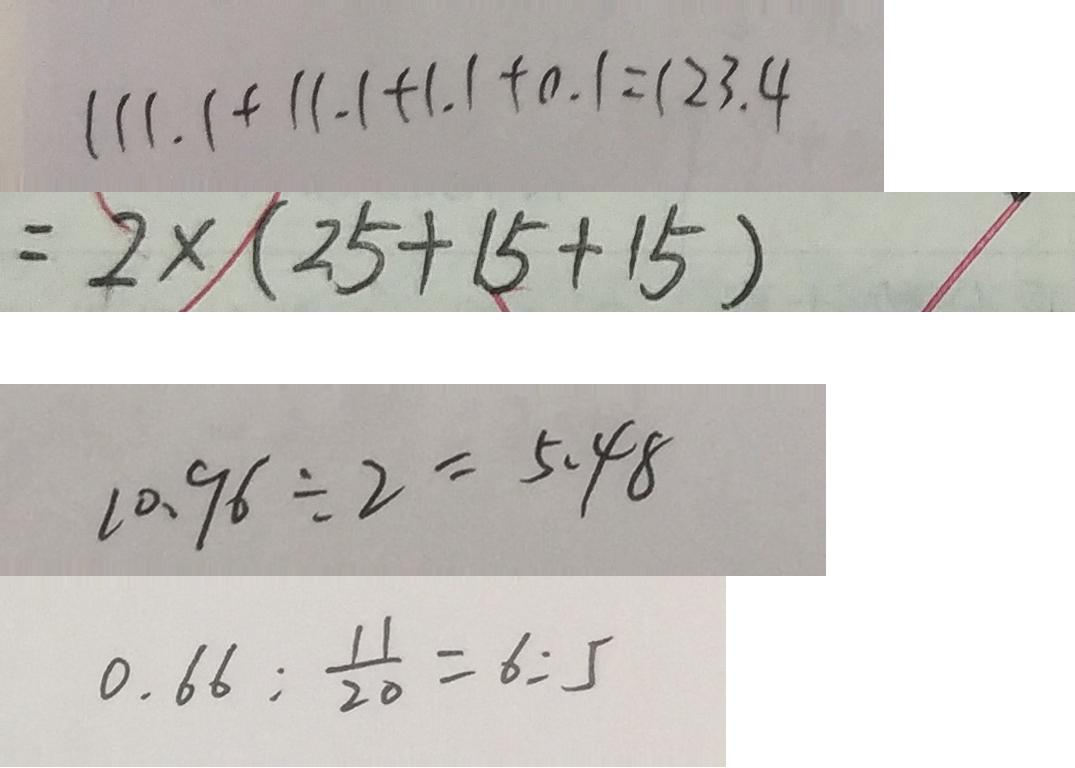Convert formula to latex. <formula><loc_0><loc_0><loc_500><loc_500>1 1 1 . 1 + 1 1 . 1 + 1 . 1 + 0 . 1 = 1 2 3 . 4 
 = 2 \times ( 2 5 + 1 5 + 1 5 ) 
 1 0 . 9 6 \div 2 = 5 . 4 8 
 0 . 6 6 : \frac { 1 1 } { 2 0 } = 6 : 5</formula> 